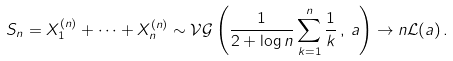<formula> <loc_0><loc_0><loc_500><loc_500>S _ { n } = X _ { 1 } ^ { ( n ) } + \dots + X _ { n } ^ { ( n ) } \sim \mathcal { V G } \left ( \frac { 1 } { 2 + \log n } \sum _ { k = 1 } ^ { n } \frac { 1 } { k } \, , \, a \right ) \to n \mathcal { L } ( a ) \, .</formula> 